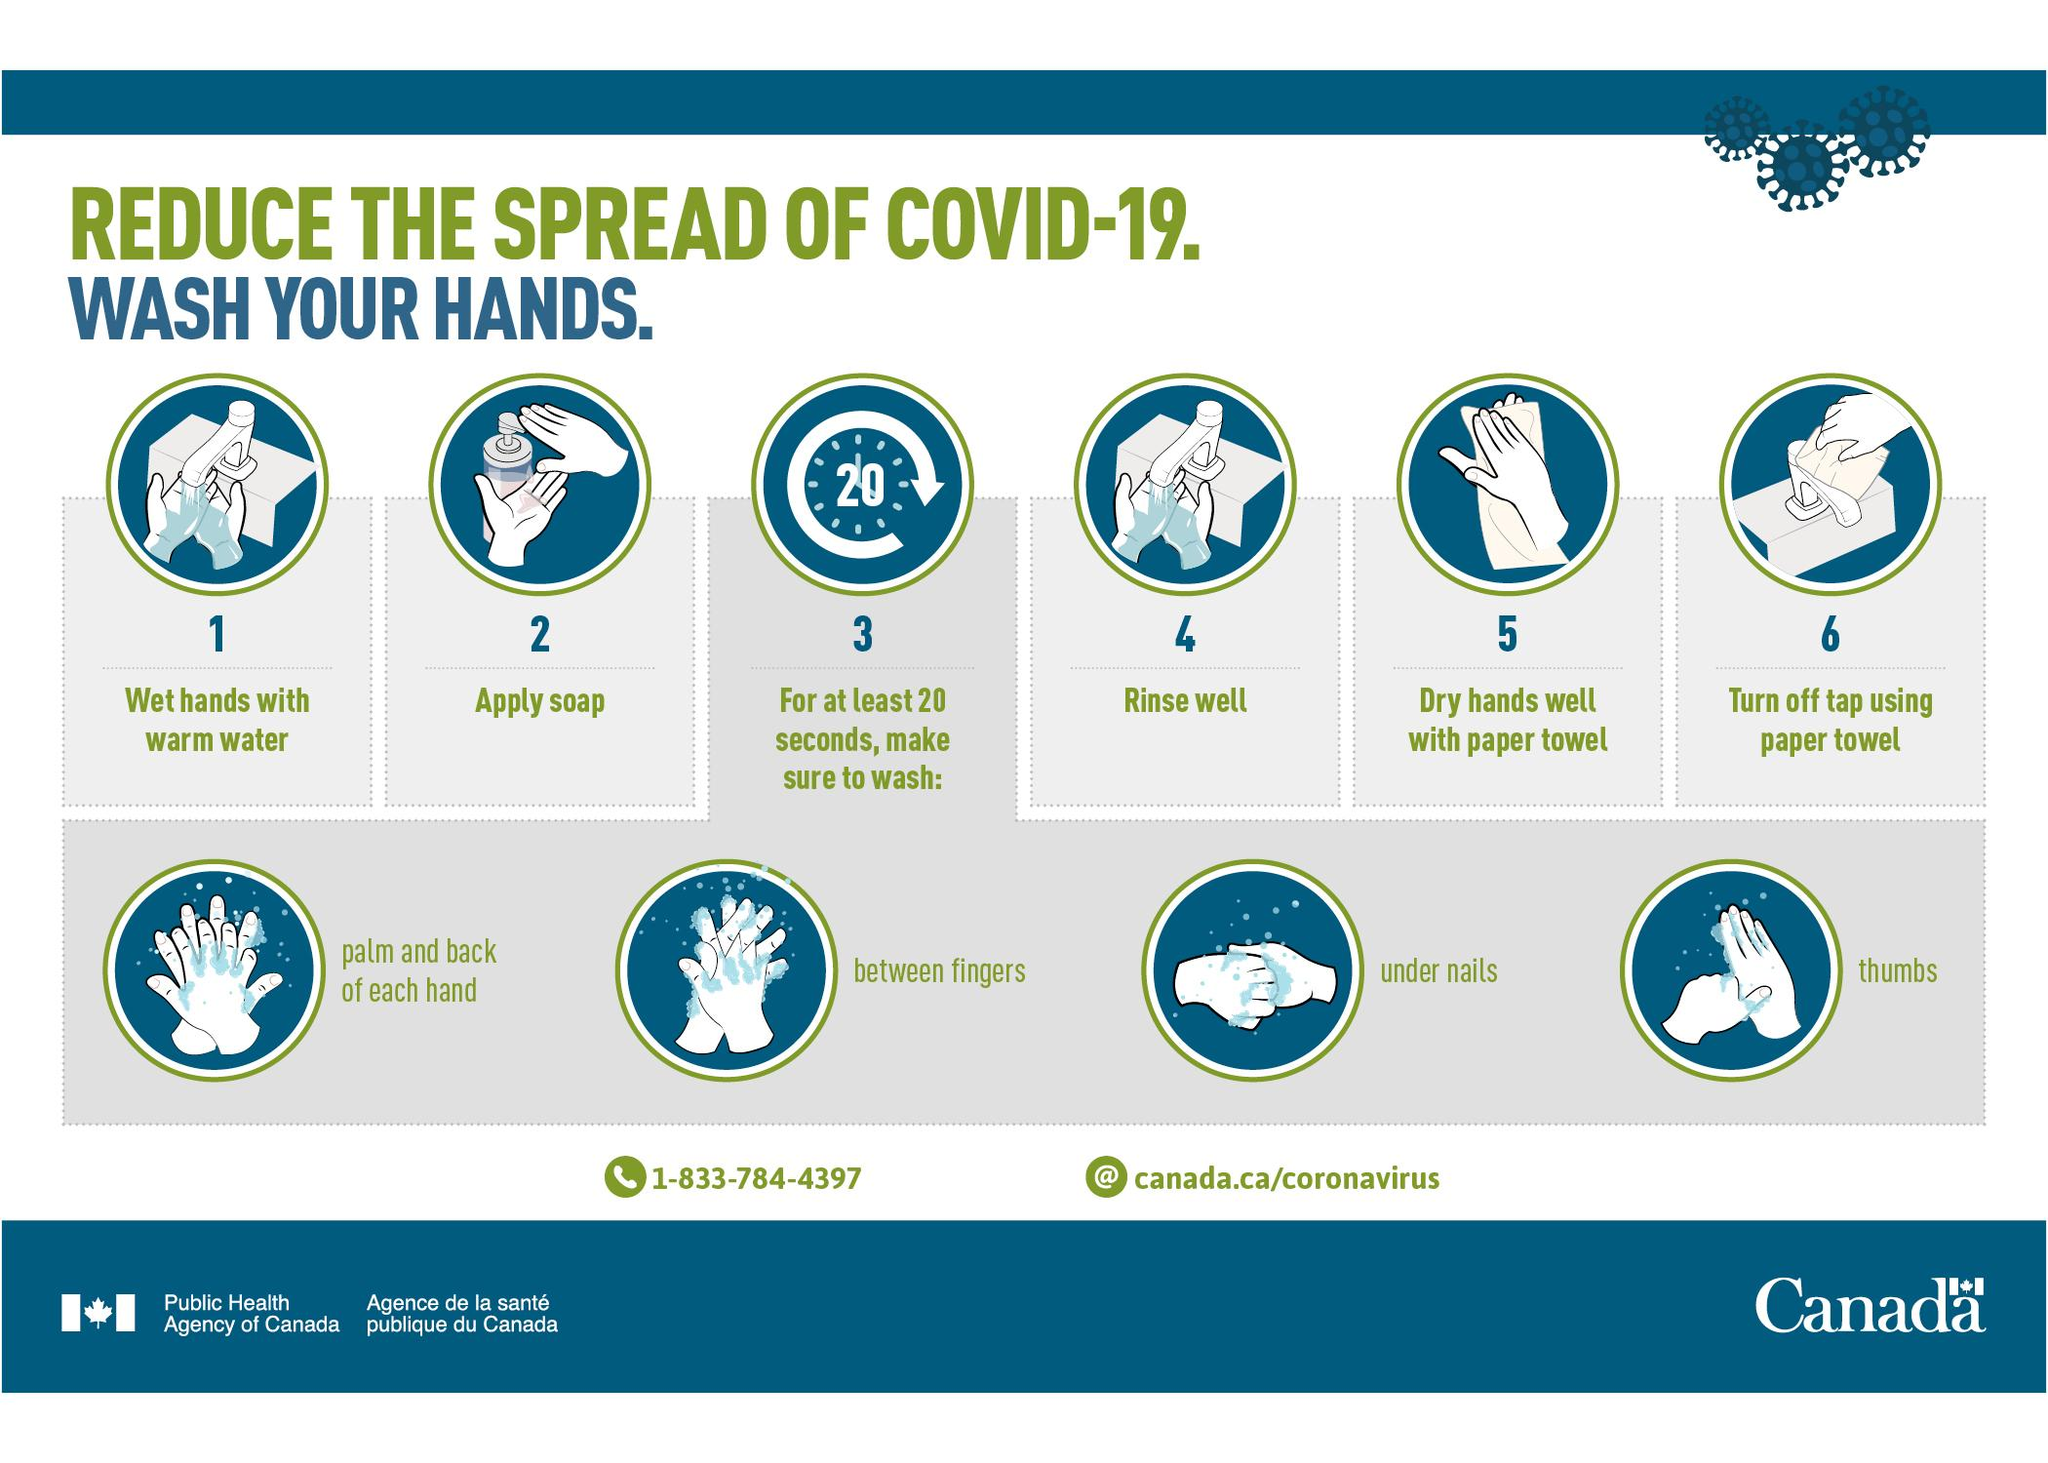Highlight a few significant elements in this photo. It is recommended to wash one's hands for at least 20 seconds in order to effectively reduce the spread of COVID-19. 